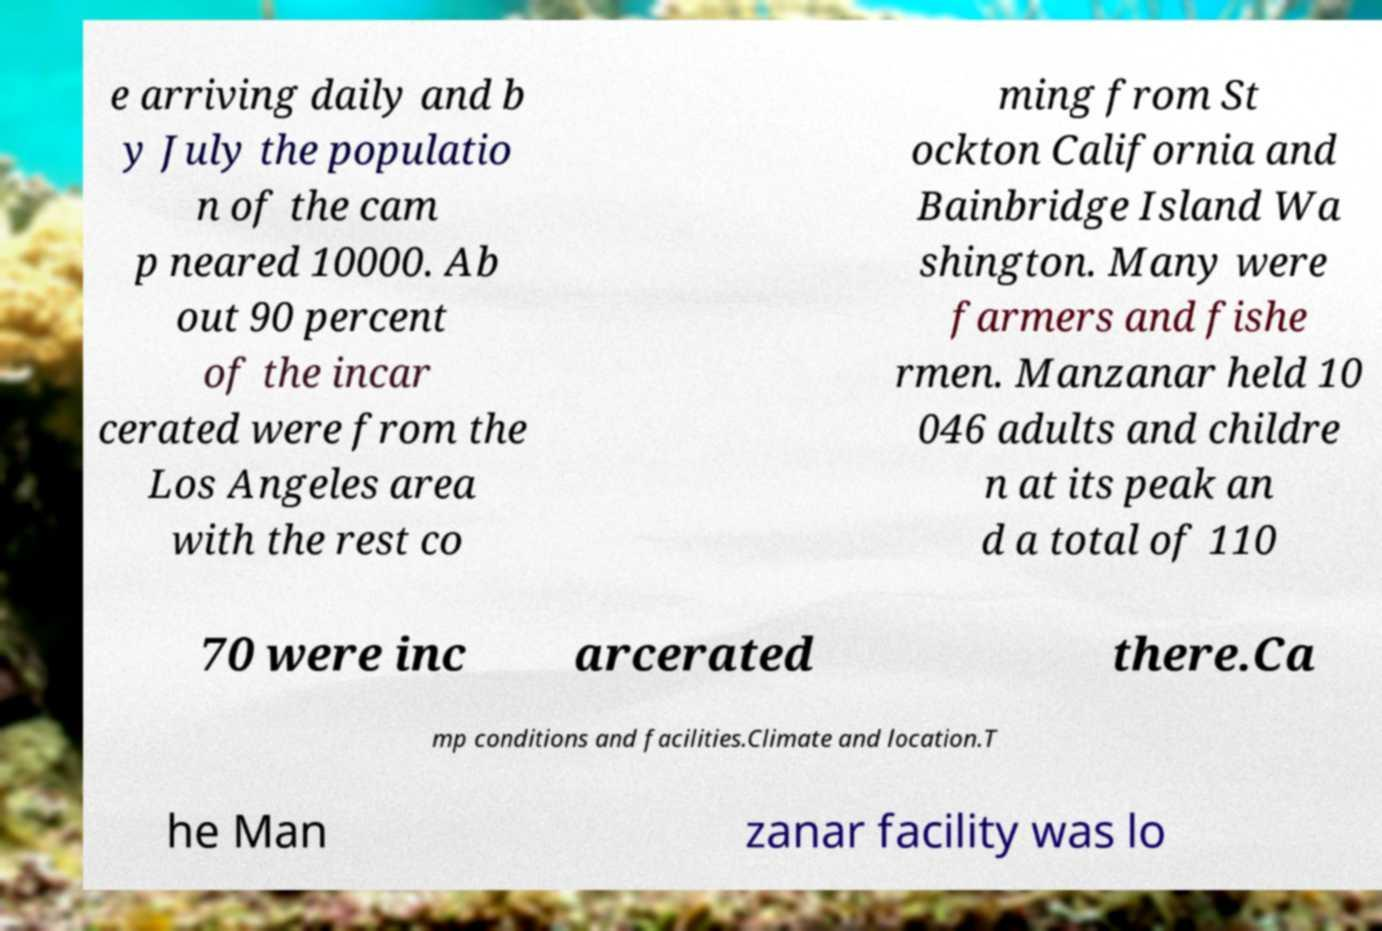For documentation purposes, I need the text within this image transcribed. Could you provide that? e arriving daily and b y July the populatio n of the cam p neared 10000. Ab out 90 percent of the incar cerated were from the Los Angeles area with the rest co ming from St ockton California and Bainbridge Island Wa shington. Many were farmers and fishe rmen. Manzanar held 10 046 adults and childre n at its peak an d a total of 110 70 were inc arcerated there.Ca mp conditions and facilities.Climate and location.T he Man zanar facility was lo 